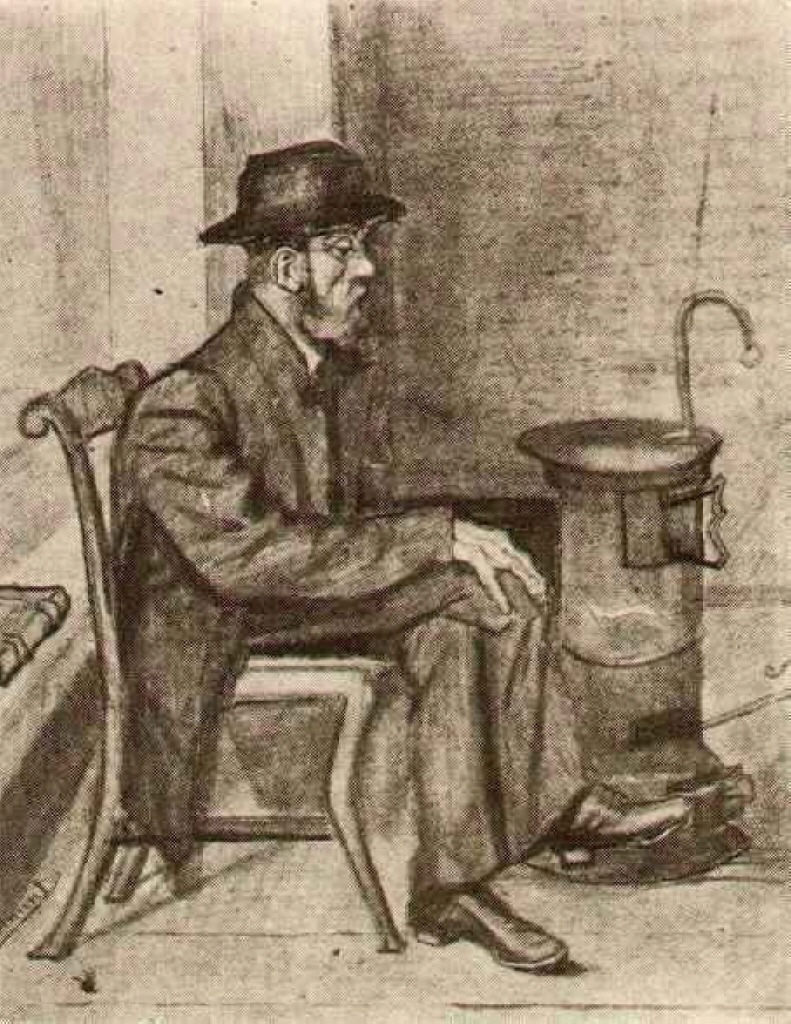Describe the man’s possible emotions and thoughts. The man appears to be in deep contemplation or possibly experiencing a moment of melancholy. His posture and the stern expression on his face suggest he is lost in thought, perhaps reflecting on personal challenges or the harshness of life during that era. His slight hunch and the tight grip on his knees indicate a sense of weariness or burden. This nuanced portrayal invites viewers to empathize with the man's internal struggles and to ponder the stories behind his thoughtful gaze. If this man were a character in a story, what might his background be? In a story, this man could be depicted as a hardworking individual, possibly a laborer or a craftsman, accustomed to a life of toil. He might have faced numerous personal and socio-economic challenges, leading to the introspective moment captured in the image. Perhaps he is a widower, reflecting on his lost love, or an immigrant reminiscing about his homeland. The image's somber and realistic style hints at a life filled with resilience, marked by both hardship and moments of quiet reflection. 